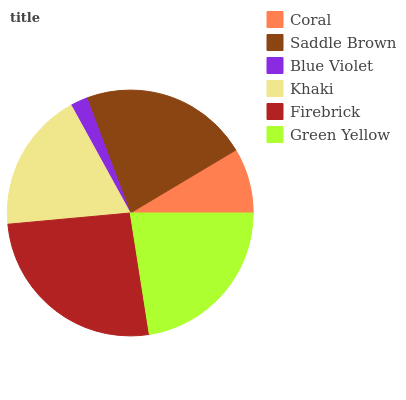Is Blue Violet the minimum?
Answer yes or no. Yes. Is Firebrick the maximum?
Answer yes or no. Yes. Is Saddle Brown the minimum?
Answer yes or no. No. Is Saddle Brown the maximum?
Answer yes or no. No. Is Saddle Brown greater than Coral?
Answer yes or no. Yes. Is Coral less than Saddle Brown?
Answer yes or no. Yes. Is Coral greater than Saddle Brown?
Answer yes or no. No. Is Saddle Brown less than Coral?
Answer yes or no. No. Is Saddle Brown the high median?
Answer yes or no. Yes. Is Khaki the low median?
Answer yes or no. Yes. Is Firebrick the high median?
Answer yes or no. No. Is Coral the low median?
Answer yes or no. No. 